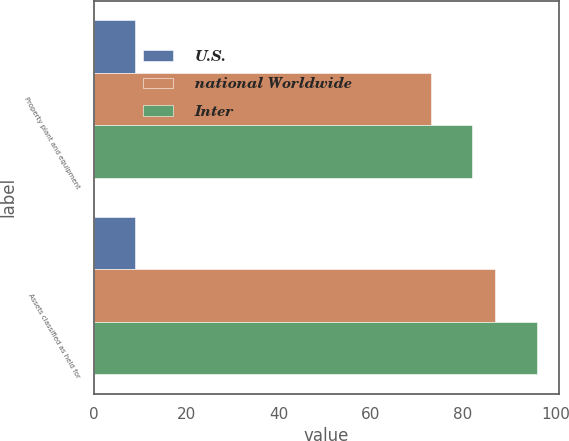<chart> <loc_0><loc_0><loc_500><loc_500><stacked_bar_chart><ecel><fcel>Property plant and equipment<fcel>Assets classified as held for<nl><fcel>U.S.<fcel>9<fcel>9<nl><fcel>national Worldwide<fcel>73<fcel>87<nl><fcel>Inter<fcel>82<fcel>96<nl></chart> 